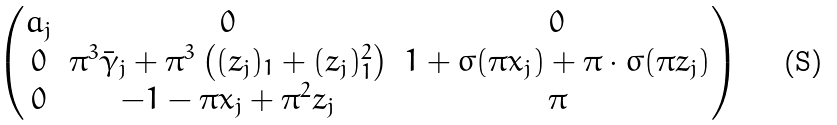Convert formula to latex. <formula><loc_0><loc_0><loc_500><loc_500>\begin{pmatrix} a _ { j } & 0 & 0 \\ 0 & \pi ^ { 3 } \bar { \gamma } _ { j } + \pi ^ { 3 } \left ( ( z _ { j } ) _ { 1 } + ( z _ { j } ) _ { 1 } ^ { 2 } \right ) & 1 + \sigma ( \pi x _ { j } ) + \pi \cdot \sigma ( \pi z _ { j } ) \\ 0 & - 1 - \pi x _ { j } + \pi ^ { 2 } z _ { j } & \pi \end{pmatrix}</formula> 